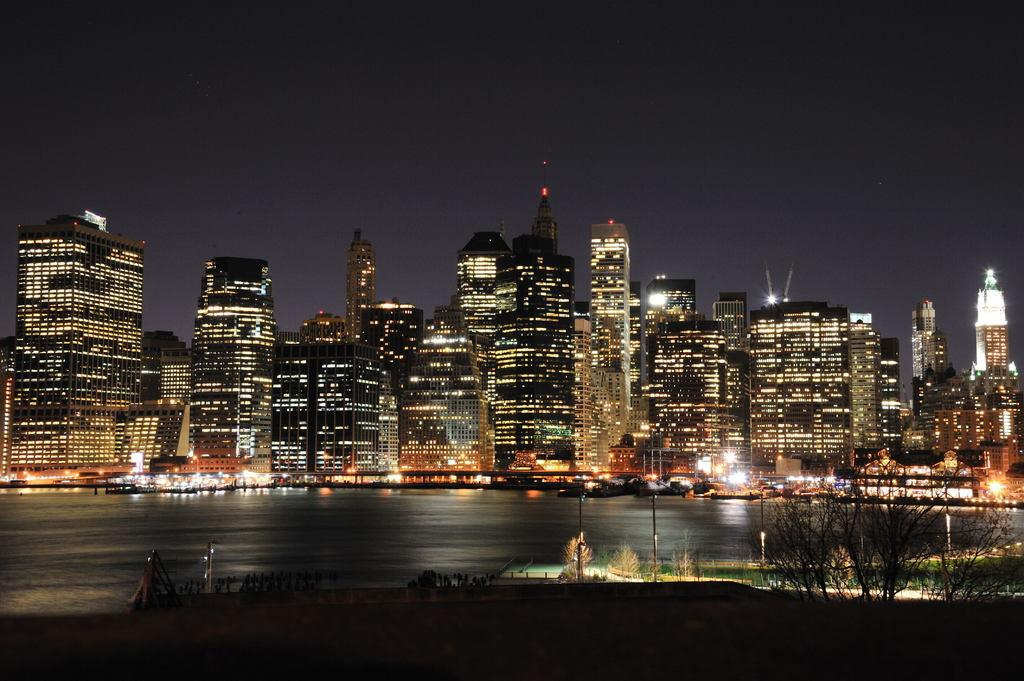What is on the water in the image? There are boats on the water in the image. What structures are present near the water? Electric poles with lights and buildings with lights are visible in the image. What type of vegetation is present in the image? Trees are present in the image. What else can be seen in the image? There are some unspecified objects in the image. What is visible in the background of the image? The sky is visible in the background of the image. Where is the tin library located in the image? There is no tin library present in the image. Can you spot a rabbit in the image? There is no rabbit present in the image. 